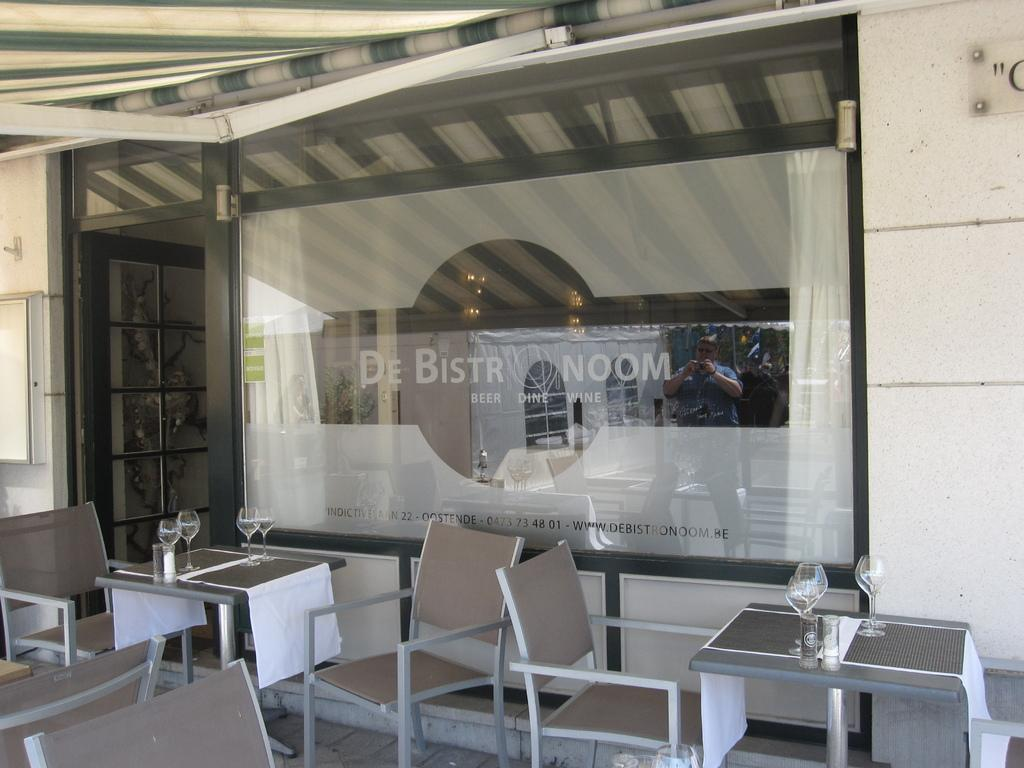<image>
Share a concise interpretation of the image provided. Restaurant store front for "De Bistro Noom" with empty tables in front. 